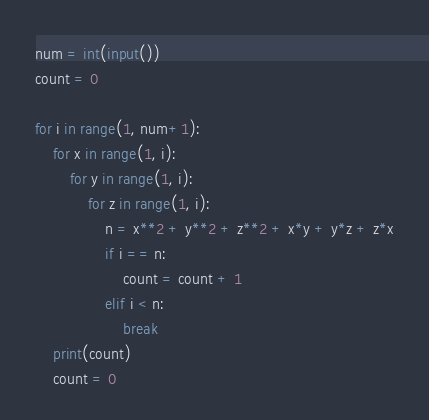Convert code to text. <code><loc_0><loc_0><loc_500><loc_500><_Python_>num = int(input())
count = 0

for i in range(1, num+1):
    for x in range(1, i):
        for y in range(1, i):
            for z in range(1, i):
                n = x**2 + y**2 + z**2 + x*y + y*z + z*x
                if i == n:
                    count = count + 1
                elif i < n:
                    break
    print(count)
    count = 0</code> 